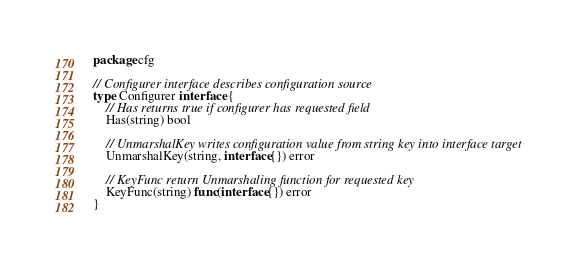Convert code to text. <code><loc_0><loc_0><loc_500><loc_500><_Go_>package cfg

// Configurer interface describes configuration source
type Configurer interface {
	// Has returns true if configurer has requested field
	Has(string) bool

	// UnmarshalKey writes configuration value from string key into interface target
	UnmarshalKey(string, interface{}) error

	// KeyFunc return Unmarshaling function for requested key
	KeyFunc(string) func(interface{}) error
}
</code> 